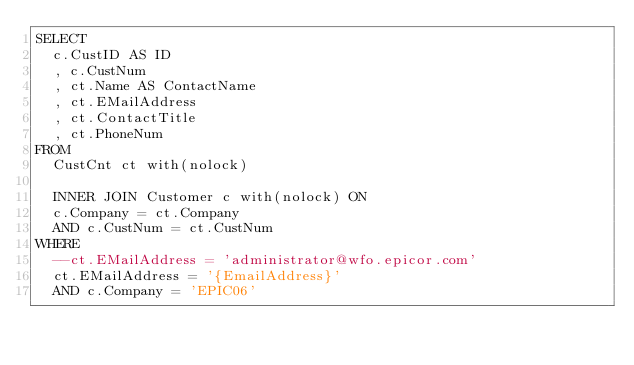Convert code to text. <code><loc_0><loc_0><loc_500><loc_500><_SQL_>SELECT
	c.CustID AS ID
	, c.CustNum
	, ct.Name AS ContactName
	, ct.EMailAddress
	, ct.ContactTitle
	, ct.PhoneNum
FROM 
	CustCnt ct with(nolock)
	
	INNER JOIN Customer c with(nolock) ON
	c.Company = ct.Company
	AND c.CustNum = ct.CustNum
WHERE
	--ct.EMailAddress = 'administrator@wfo.epicor.com'
	ct.EMailAddress = '{EmailAddress}'
	AND c.Company = 'EPIC06'</code> 